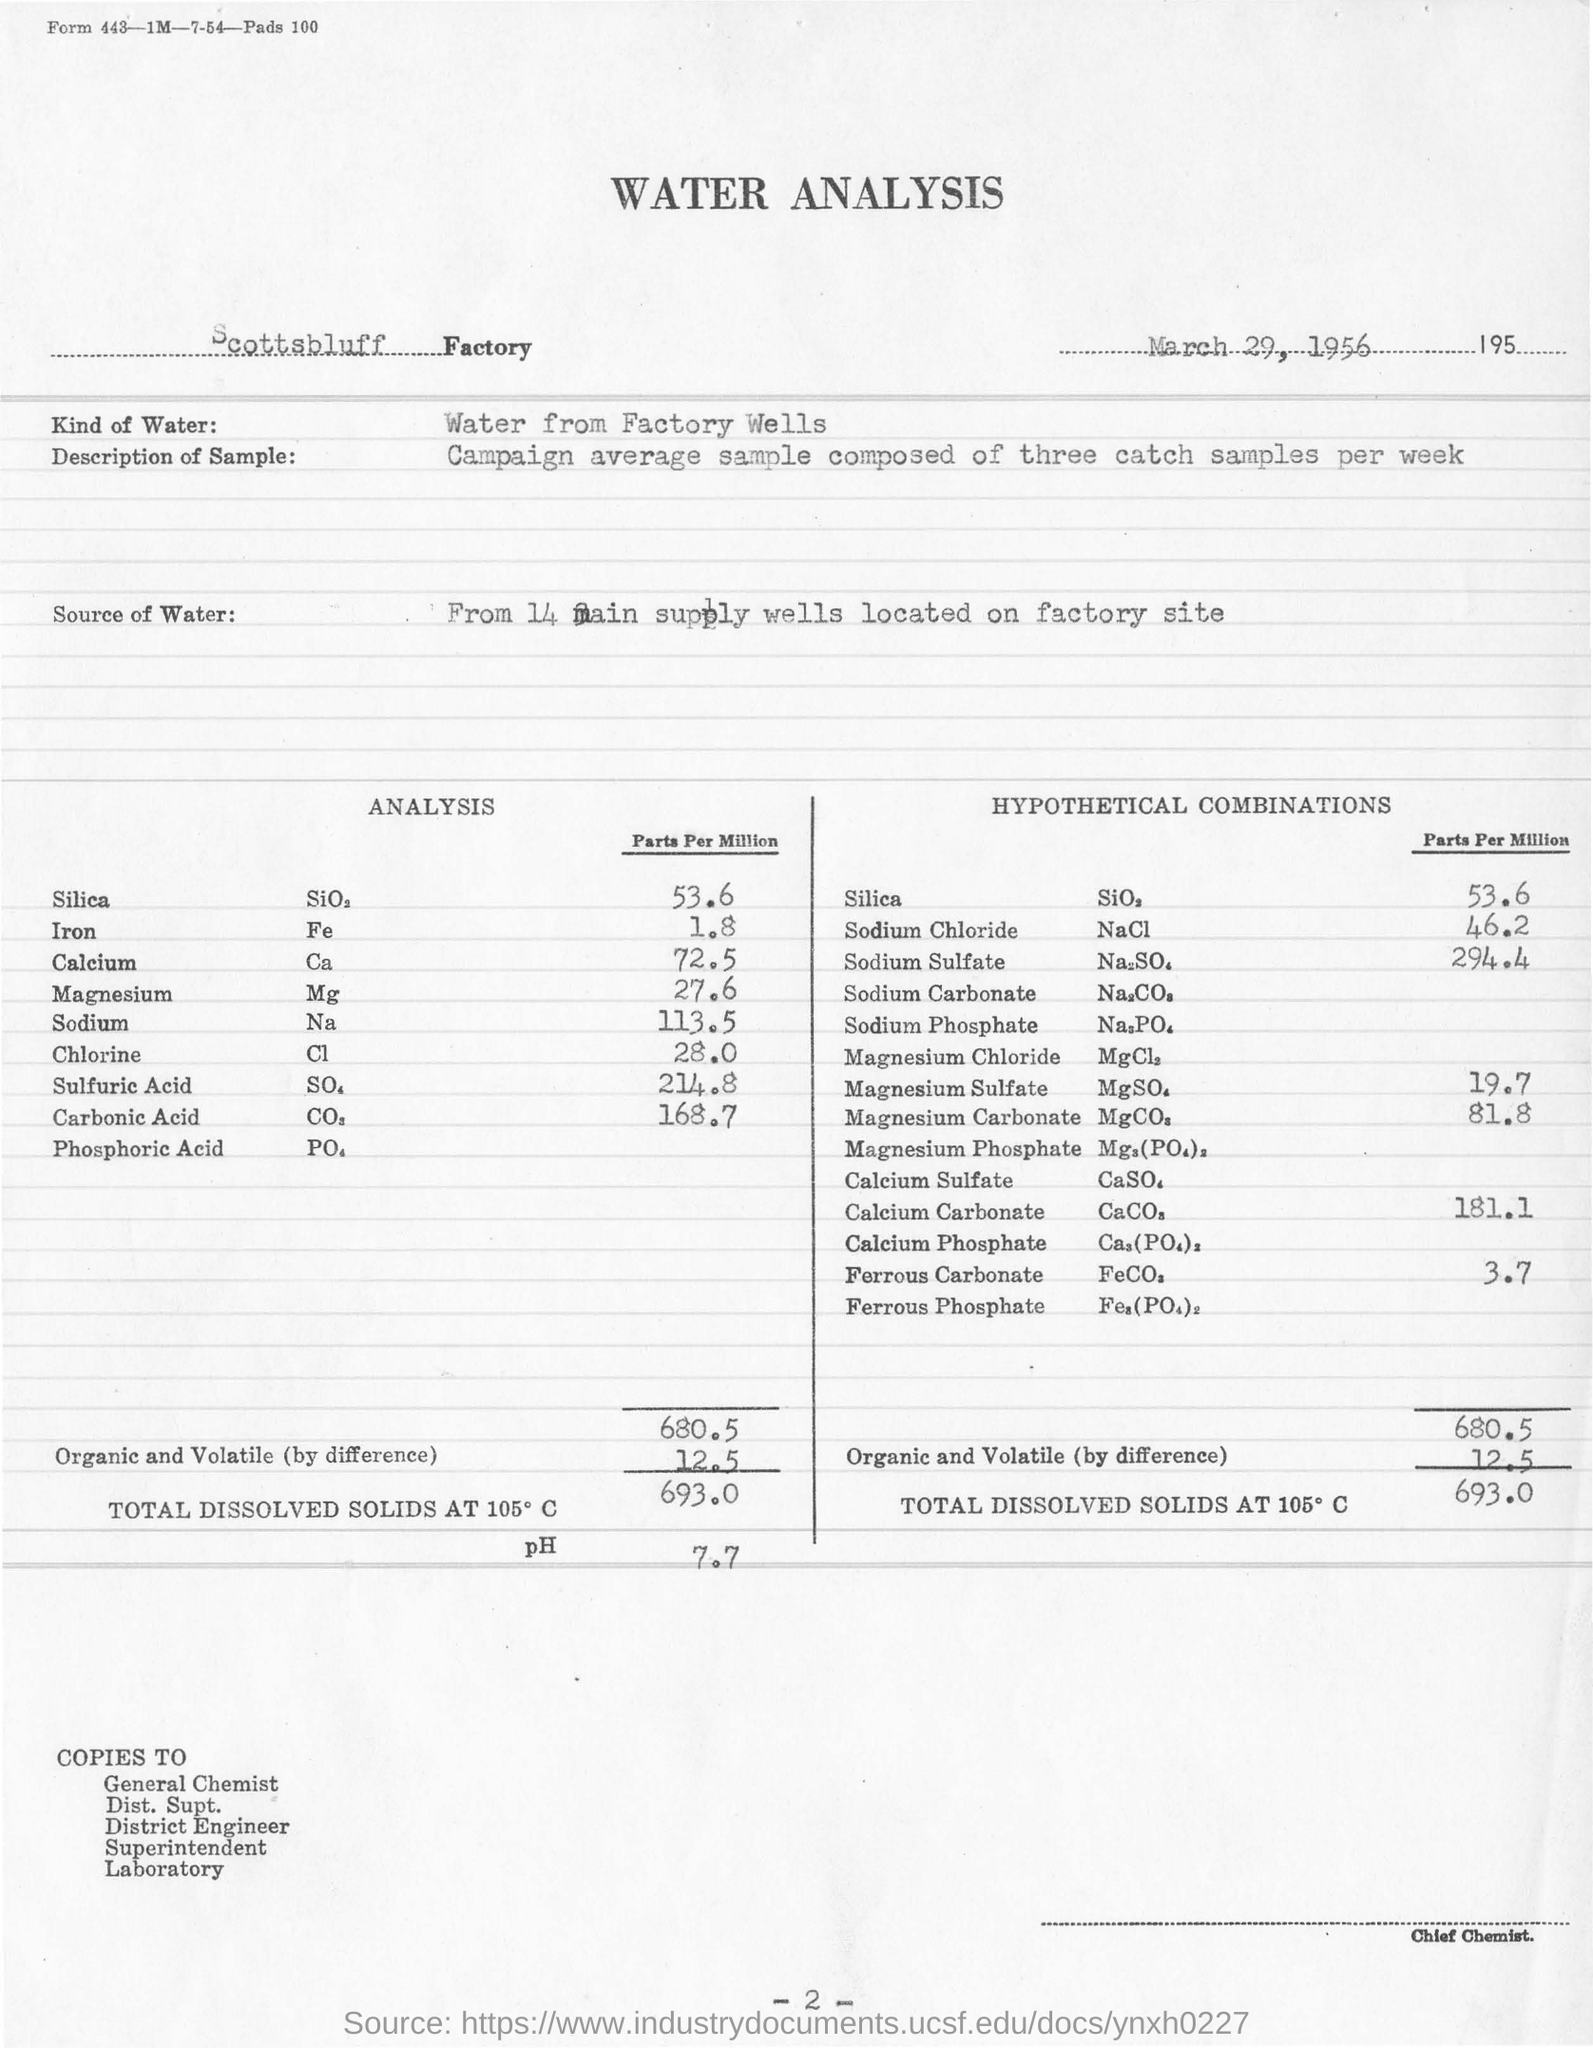In which factory is the water analysis done?
Your answer should be compact. Scottsbluff Factory. What is the date mentioned in the document?
Provide a short and direct response. March 29, 1956. What kind of water used for analysis ?
Provide a succinct answer. Water from factory wells. What is the parts per million analysis for Calcium ?
Your answer should be very brief. 72.5. What is the chemical formula for Chlorine ?
Ensure brevity in your answer.  Cl. What is the parts per million analysis for Iron ?
Your response must be concise. 1 8. What is the chemical formula for Sodium ?
Provide a short and direct response. Na. What is the parts per million analysis for Silica ?
Keep it short and to the point. 53 6. What is parts per million analysis for Calcium Carbonate
Offer a terse response. 181 1. 